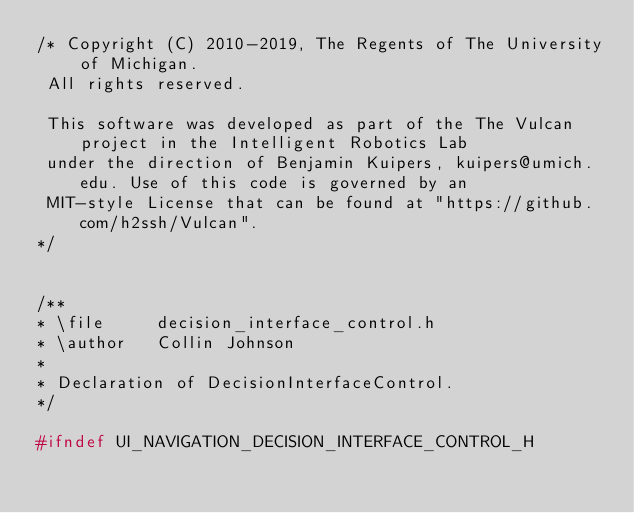<code> <loc_0><loc_0><loc_500><loc_500><_C_>/* Copyright (C) 2010-2019, The Regents of The University of Michigan.
 All rights reserved.

 This software was developed as part of the The Vulcan project in the Intelligent Robotics Lab
 under the direction of Benjamin Kuipers, kuipers@umich.edu. Use of this code is governed by an
 MIT-style License that can be found at "https://github.com/h2ssh/Vulcan".
*/


/**
* \file     decision_interface_control.h
* \author   Collin Johnson
*
* Declaration of DecisionInterfaceControl.
*/

#ifndef UI_NAVIGATION_DECISION_INTERFACE_CONTROL_H</code> 